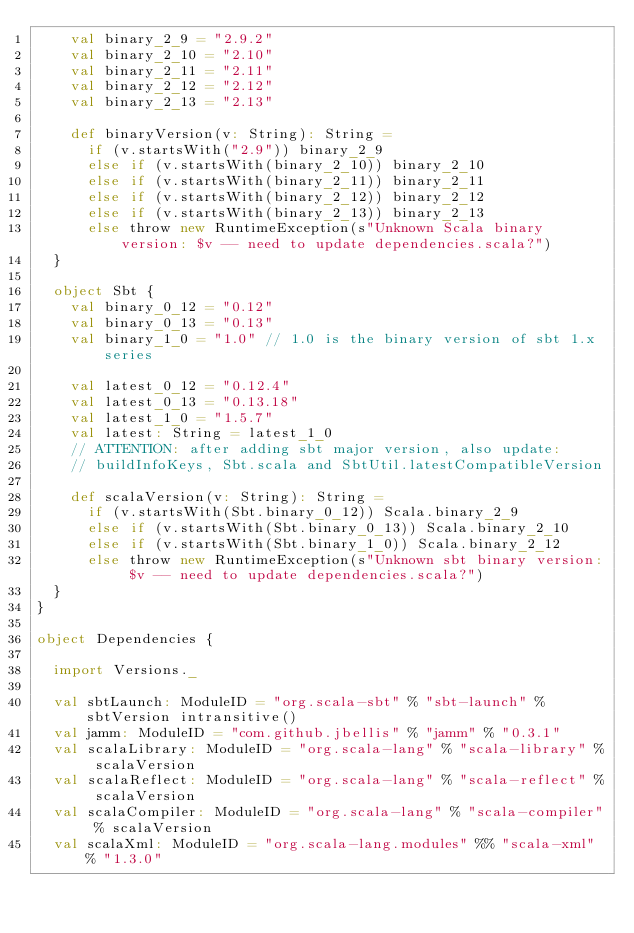<code> <loc_0><loc_0><loc_500><loc_500><_Scala_>    val binary_2_9 = "2.9.2"
    val binary_2_10 = "2.10"
    val binary_2_11 = "2.11"
    val binary_2_12 = "2.12"
    val binary_2_13 = "2.13"

    def binaryVersion(v: String): String =
      if (v.startsWith("2.9")) binary_2_9
      else if (v.startsWith(binary_2_10)) binary_2_10
      else if (v.startsWith(binary_2_11)) binary_2_11
      else if (v.startsWith(binary_2_12)) binary_2_12
      else if (v.startsWith(binary_2_13)) binary_2_13
      else throw new RuntimeException(s"Unknown Scala binary version: $v -- need to update dependencies.scala?")
  }

  object Sbt {
    val binary_0_12 = "0.12"
    val binary_0_13 = "0.13"
    val binary_1_0 = "1.0" // 1.0 is the binary version of sbt 1.x series

    val latest_0_12 = "0.12.4"
    val latest_0_13 = "0.13.18"
    val latest_1_0 = "1.5.7"
    val latest: String = latest_1_0
    // ATTENTION: after adding sbt major version, also update:
    // buildInfoKeys, Sbt.scala and SbtUtil.latestCompatibleVersion

    def scalaVersion(v: String): String =
      if (v.startsWith(Sbt.binary_0_12)) Scala.binary_2_9
      else if (v.startsWith(Sbt.binary_0_13)) Scala.binary_2_10
      else if (v.startsWith(Sbt.binary_1_0)) Scala.binary_2_12
      else throw new RuntimeException(s"Unknown sbt binary version: $v -- need to update dependencies.scala?")
  }
}

object Dependencies {

  import Versions._

  val sbtLaunch: ModuleID = "org.scala-sbt" % "sbt-launch" % sbtVersion intransitive()
  val jamm: ModuleID = "com.github.jbellis" % "jamm" % "0.3.1"
  val scalaLibrary: ModuleID = "org.scala-lang" % "scala-library" % scalaVersion
  val scalaReflect: ModuleID = "org.scala-lang" % "scala-reflect" % scalaVersion
  val scalaCompiler: ModuleID = "org.scala-lang" % "scala-compiler" % scalaVersion
  val scalaXml: ModuleID = "org.scala-lang.modules" %% "scala-xml" % "1.3.0"</code> 